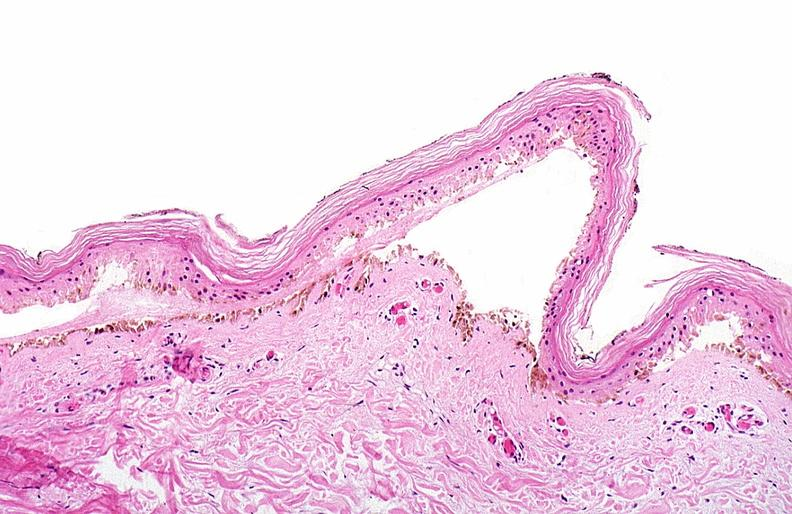does amyloidosis show thermal burned skin?
Answer the question using a single word or phrase. No 